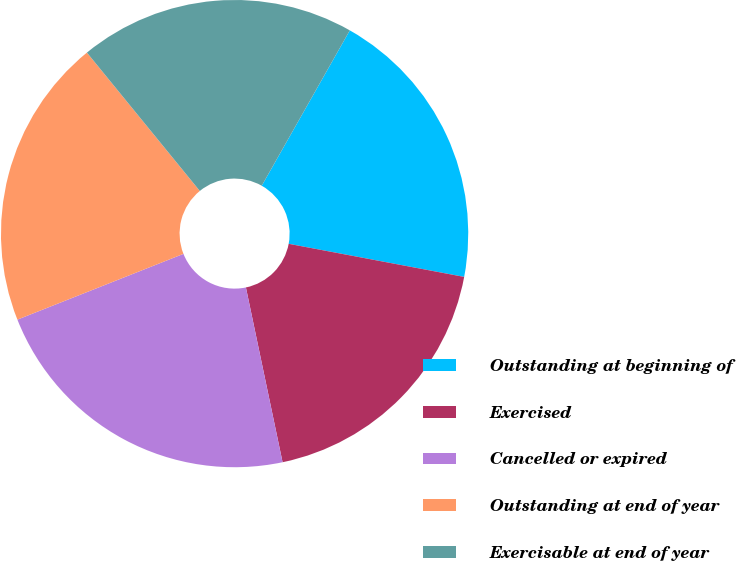<chart> <loc_0><loc_0><loc_500><loc_500><pie_chart><fcel>Outstanding at beginning of<fcel>Exercised<fcel>Cancelled or expired<fcel>Outstanding at end of year<fcel>Exercisable at end of year<nl><fcel>19.76%<fcel>18.74%<fcel>22.29%<fcel>20.11%<fcel>19.1%<nl></chart> 